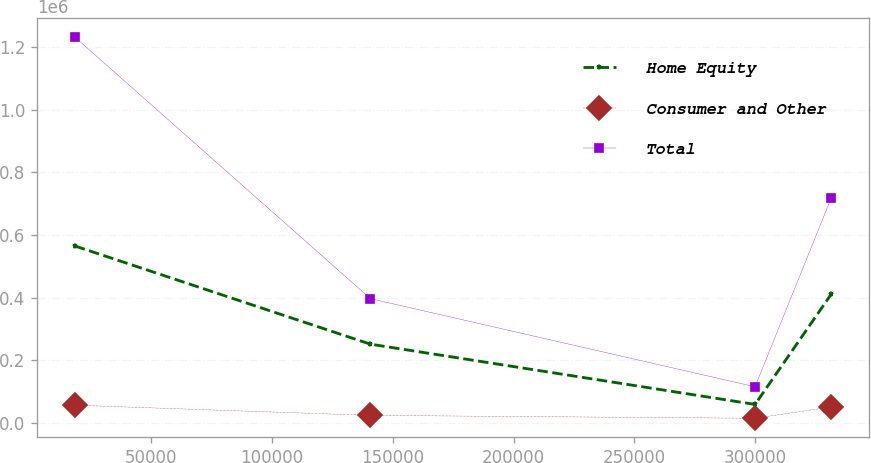<chart> <loc_0><loc_0><loc_500><loc_500><line_chart><ecel><fcel>Home Equity<fcel>Consumer and Other<fcel>Total<nl><fcel>18271.7<fcel>564741<fcel>56451.6<fcel>1.23155e+06<nl><fcel>140672<fcel>251316<fcel>24014.8<fcel>396587<nl><fcel>299955<fcel>59047.1<fcel>14826<fcel>115370<nl><fcel>331565<fcel>411672<fcel>51114.7<fcel>719376<nl></chart> 